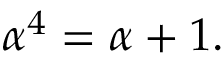Convert formula to latex. <formula><loc_0><loc_0><loc_500><loc_500>\alpha ^ { 4 } = \alpha + 1 .</formula> 